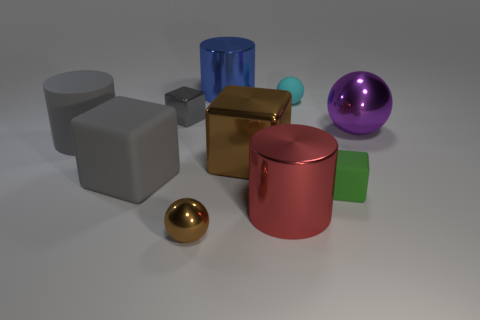Subtract 1 cubes. How many cubes are left? 3 Subtract all blocks. How many objects are left? 6 Add 6 matte cubes. How many matte cubes exist? 8 Subtract 1 brown spheres. How many objects are left? 9 Subtract all large green shiny spheres. Subtract all red objects. How many objects are left? 9 Add 1 red shiny cylinders. How many red shiny cylinders are left? 2 